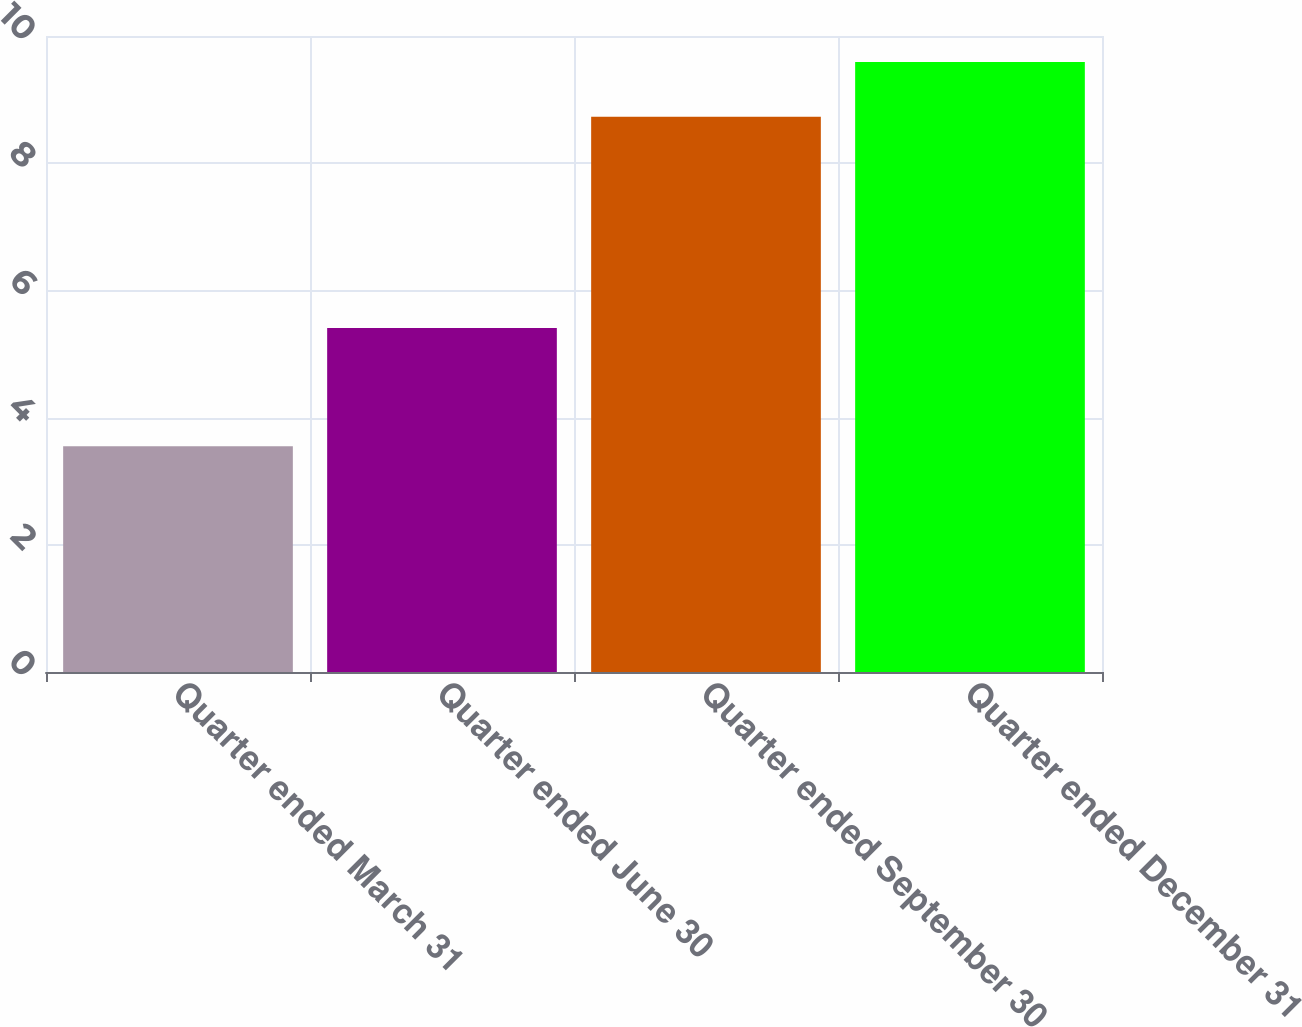Convert chart to OTSL. <chart><loc_0><loc_0><loc_500><loc_500><bar_chart><fcel>Quarter ended March 31<fcel>Quarter ended June 30<fcel>Quarter ended September 30<fcel>Quarter ended December 31<nl><fcel>3.55<fcel>5.41<fcel>8.73<fcel>9.59<nl></chart> 